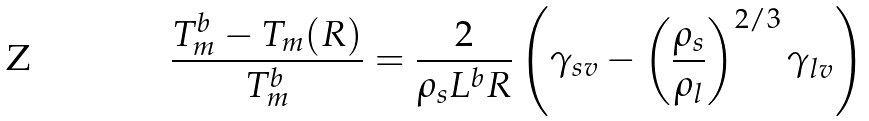<formula> <loc_0><loc_0><loc_500><loc_500>\frac { T _ { m } ^ { b } - T _ { m } ( R ) } { T _ { m } ^ { b } } = \frac { 2 } { \rho _ { s } L ^ { b } R } \left ( \gamma _ { s v } - \left ( \frac { \rho _ { s } } { \rho _ { l } } \right ) ^ { 2 / 3 } \gamma _ { l v } \right )</formula> 